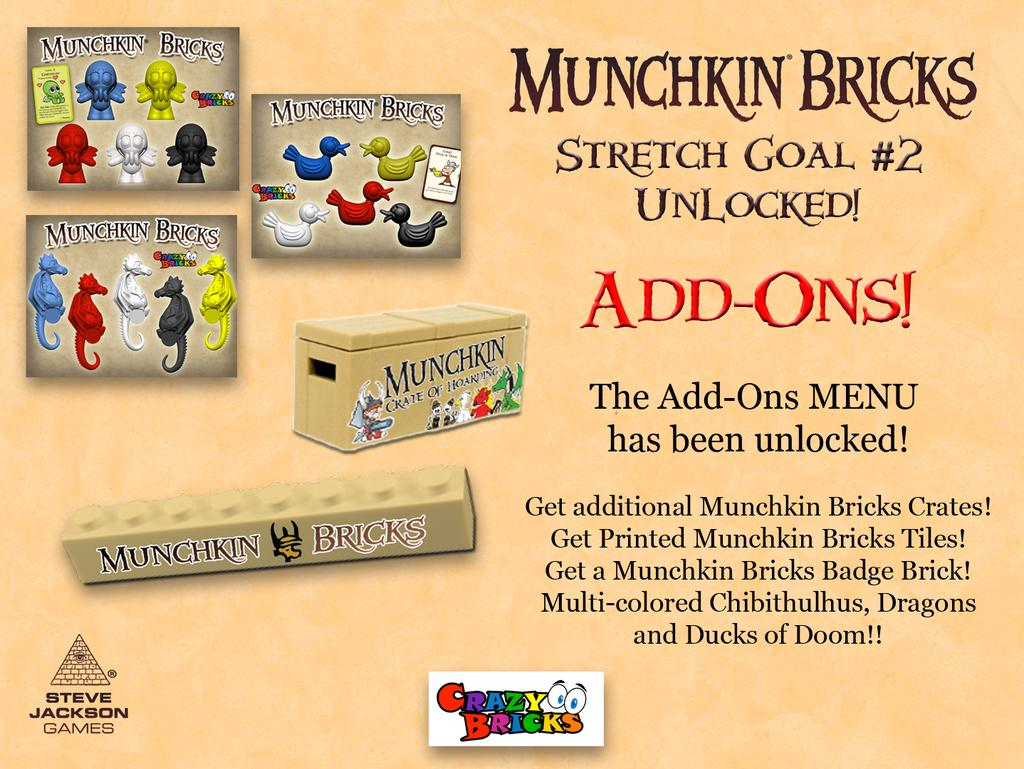<image>
Give a short and clear explanation of the subsequent image. A poster for children's toys advertises Munchkin Bricks. 